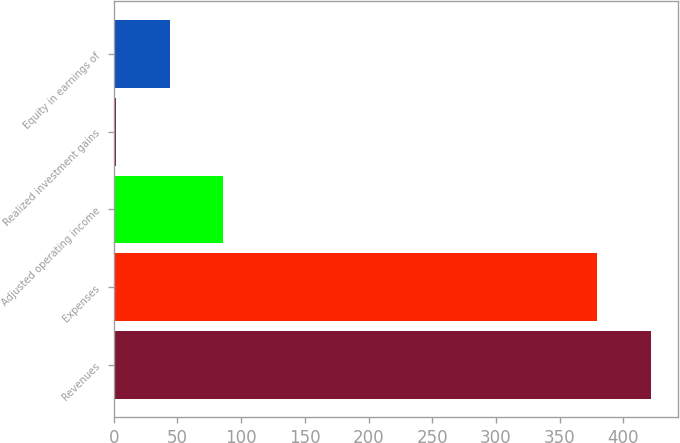Convert chart to OTSL. <chart><loc_0><loc_0><loc_500><loc_500><bar_chart><fcel>Revenues<fcel>Expenses<fcel>Adjusted operating income<fcel>Realized investment gains<fcel>Equity in earnings of<nl><fcel>422<fcel>379<fcel>86<fcel>2<fcel>44<nl></chart> 